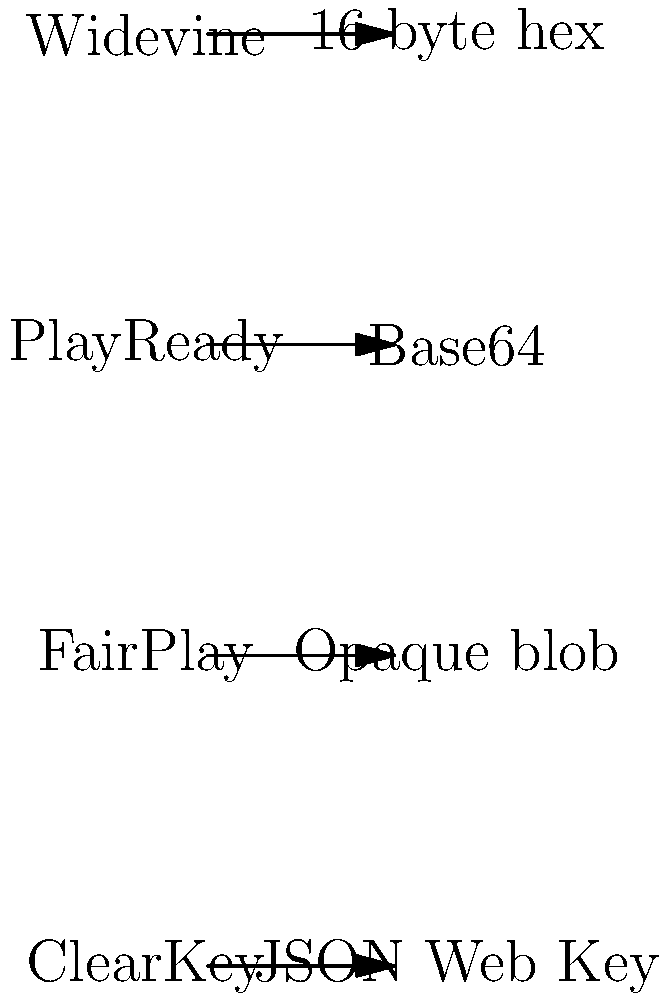Match the encryption key patterns to their corresponding content protection schemes used in EME (Encrypted Media Extensions). Which pattern is associated with the ClearKey scheme? To answer this question, we need to understand the key patterns used by different content protection schemes in EME:

1. Widevine: Uses a 16-byte hexadecimal key ID.
2. PlayReady: Typically uses a Base64 encoded key ID.
3. FairPlay: Uses an opaque blob for its key system.
4. ClearKey: Uses a JSON Web Key (JWK) format.

The ClearKey scheme is designed to be a simple and open content protection system. It uses the JSON Web Key (JWK) format to represent keys. This format is a JSON object that contains the key ID and the actual key value, both typically encoded in Base64.

For example, a ClearKey JWK might look like this:

```json
{
  "keys": [{
    "kty": "oct",
    "k": "base64EncodedKey",
    "kid": "base64EncodedKeyId"
  }]
}
```

This JSON structure is what distinguishes ClearKey from other content protection schemes and their key formats.
Answer: JSON Web Key 